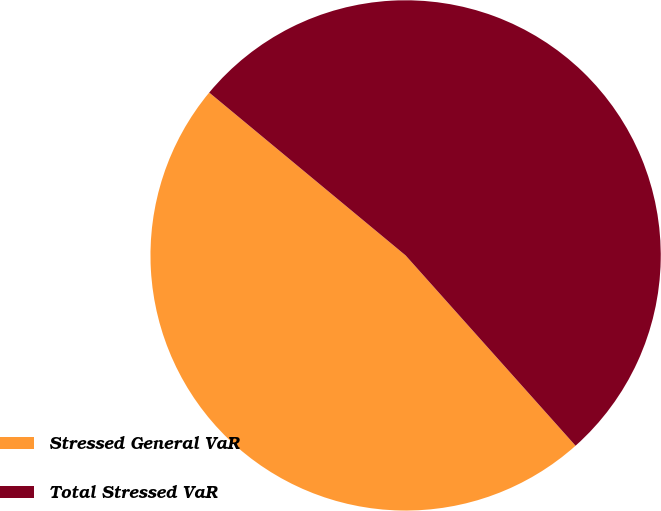Convert chart. <chart><loc_0><loc_0><loc_500><loc_500><pie_chart><fcel>Stressed General VaR<fcel>Total Stressed VaR<nl><fcel>47.62%<fcel>52.38%<nl></chart> 